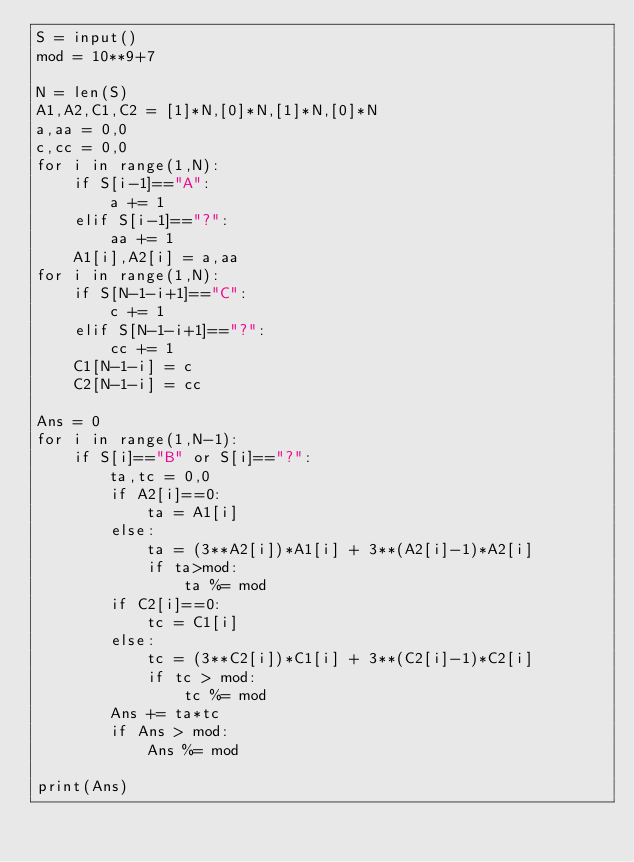<code> <loc_0><loc_0><loc_500><loc_500><_Python_>S = input()
mod = 10**9+7

N = len(S)
A1,A2,C1,C2 = [1]*N,[0]*N,[1]*N,[0]*N
a,aa = 0,0
c,cc = 0,0
for i in range(1,N):
    if S[i-1]=="A":
        a += 1
    elif S[i-1]=="?":
        aa += 1
    A1[i],A2[i] = a,aa
for i in range(1,N):
    if S[N-1-i+1]=="C":
        c += 1
    elif S[N-1-i+1]=="?":
        cc += 1
    C1[N-1-i] = c
    C2[N-1-i] = cc

Ans = 0
for i in range(1,N-1):
    if S[i]=="B" or S[i]=="?":
        ta,tc = 0,0
        if A2[i]==0:
            ta = A1[i]
        else:
            ta = (3**A2[i])*A1[i] + 3**(A2[i]-1)*A2[i]
            if ta>mod:
                ta %= mod
        if C2[i]==0:
            tc = C1[i]
        else:
            tc = (3**C2[i])*C1[i] + 3**(C2[i]-1)*C2[i]
            if tc > mod:
                tc %= mod
        Ans += ta*tc
        if Ans > mod:
            Ans %= mod

print(Ans)</code> 